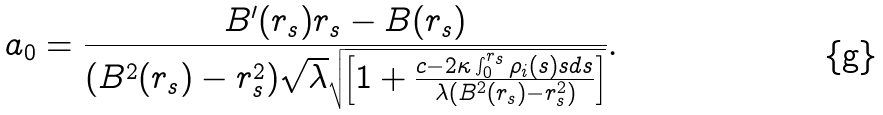Convert formula to latex. <formula><loc_0><loc_0><loc_500><loc_500>a _ { 0 } = \frac { B ^ { \prime } ( r _ { s } ) r _ { s } - B ( r _ { s } ) } { ( B ^ { 2 } ( r _ { s } ) - r _ { s } ^ { 2 } ) \sqrt { \lambda } \sqrt { \left [ 1 + \frac { c - 2 \kappa \int _ { 0 } ^ { r _ { s } } { \rho _ { i } ( s ) s d s } } { \lambda ( B ^ { 2 } ( r _ { s } ) - r _ { s } ^ { 2 } ) } \right ] } } .</formula> 